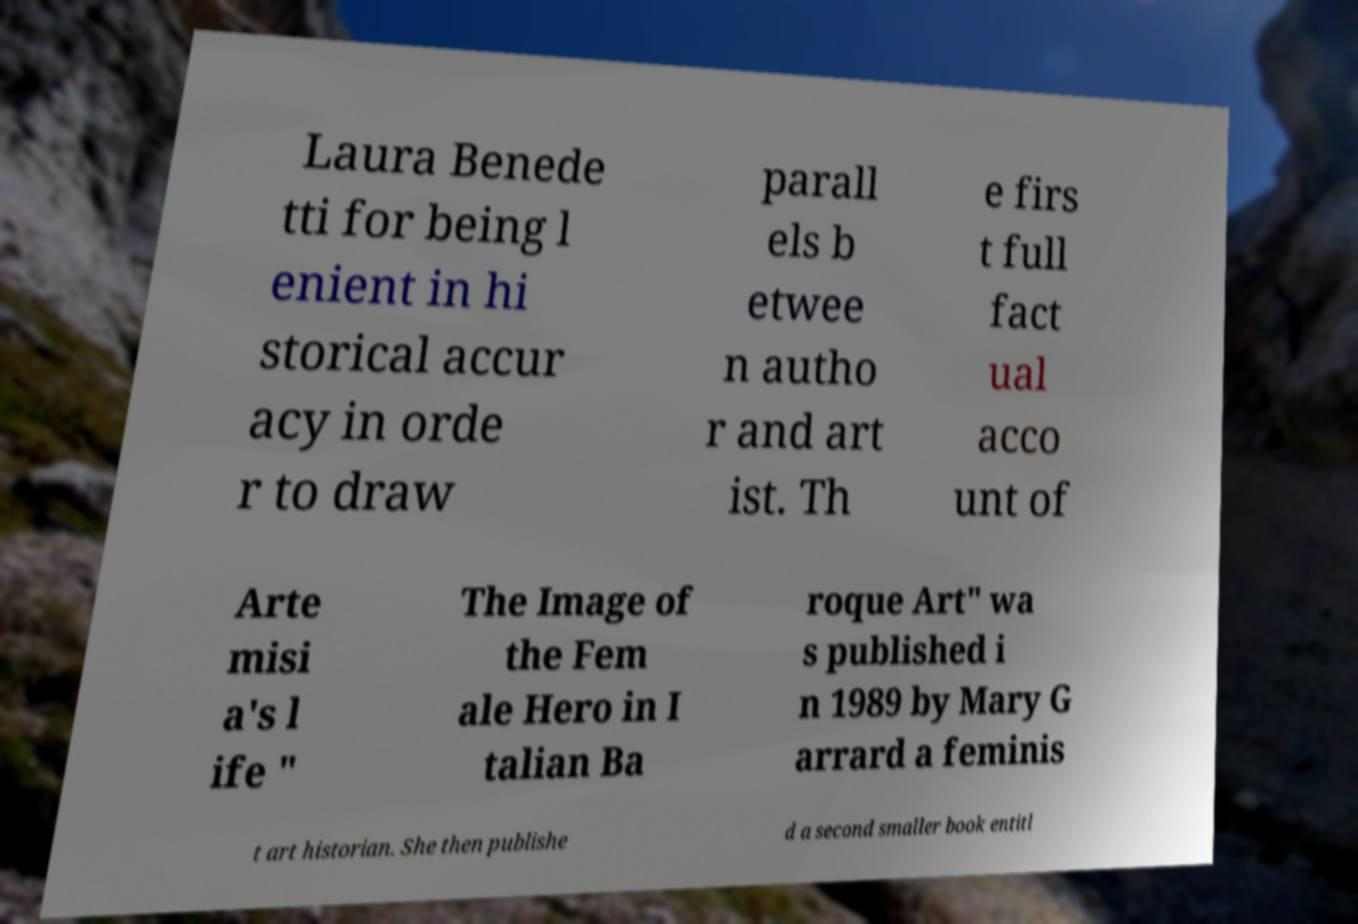Could you assist in decoding the text presented in this image and type it out clearly? Laura Benede tti for being l enient in hi storical accur acy in orde r to draw parall els b etwee n autho r and art ist. Th e firs t full fact ual acco unt of Arte misi a's l ife " The Image of the Fem ale Hero in I talian Ba roque Art" wa s published i n 1989 by Mary G arrard a feminis t art historian. She then publishe d a second smaller book entitl 